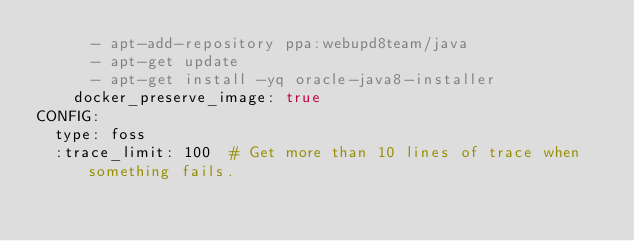<code> <loc_0><loc_0><loc_500><loc_500><_YAML_>      - apt-add-repository ppa:webupd8team/java
      - apt-get update
      - apt-get install -yq oracle-java8-installer
    docker_preserve_image: true
CONFIG:
  type: foss
  :trace_limit: 100  # Get more than 10 lines of trace when something fails.
</code> 